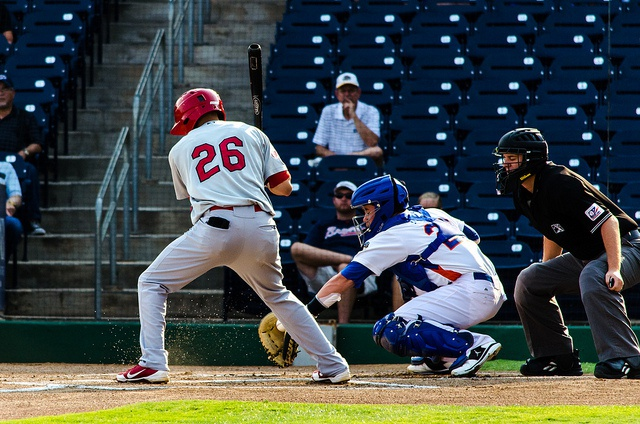Describe the objects in this image and their specific colors. I can see people in black, darkgray, lightblue, and lightgray tones, people in black, navy, gray, and brown tones, people in black, lavender, navy, and darkgray tones, people in black, gray, maroon, and darkgray tones, and people in black, darkgray, gray, and maroon tones in this image. 